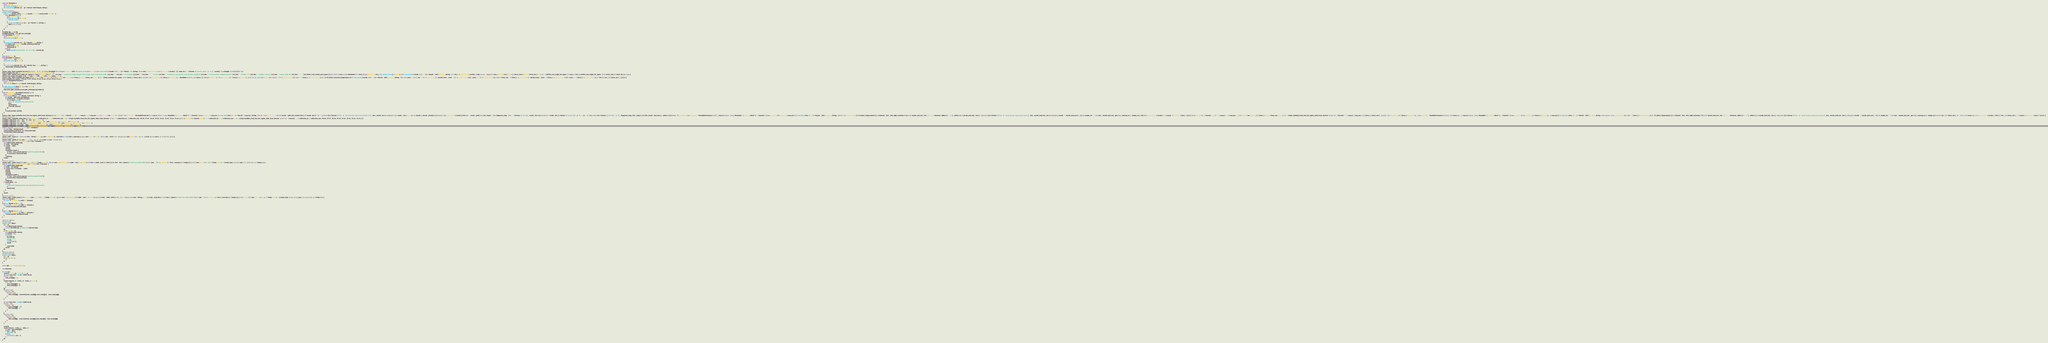Convert code to text. <code><loc_0><loc_0><loc_500><loc_500><_Rust_>pub trait Readable {
    type Output;
    fn words_count() -> usize;
    fn read_words(words: &[&str]) -> Result<Self::Output, String>;
}
#[macro_export]
macro_rules! readable {
    ( $ t : ty , $ words_count : expr , |$ words : ident | $ read_words : expr ) => {
        impl Readable for $t {
            type Output = $t;
            fn words_count() -> usize {
                $words_count
            }
            fn read_words($words: &[&str]) -> Result<$t, String> {
                Ok($read_words)
            }
        }
    };
}
readable!((), 1, |_ss| ());
readable!(String, 1, |ss| ss[0].to_string());
impl Readable for char {
    type Output = char;
    fn words_count() -> usize {
        1
    }
    fn read_words(words: &[&str]) -> Result<char, String> {
        let chars: Vec<char> = words[0].chars().collect();
        if chars.len() == 1 {
            Ok(chars[0])
        } else {
            Err(format!("cannot parse `{}` as a char", words[0]))
        }
    }
}
pub struct Chars();
impl Readable for Chars {
    type Output = Vec<char>;
    fn words_count() -> usize {
        1
    }
    fn read_words(words: &[&str]) -> Result<Vec<char>, String> {
        Ok(words[0].chars().collect())
    }
}
macro_rules ! impl_readable_for_ints { ( $ ( $ t : ty ) * ) => { $ ( impl Readable for $ t { type Output = Self ; fn words_count ( ) -> usize { 1 } fn read_words ( words : & [ & str ] ) -> Result <$ t , String > { use std :: str :: FromStr ; <$ t >:: from_str ( words [ 0 ] ) . map_err ( | _ | { format ! ( "cannot parse `{}` as {}" , words [ 0 ] , stringify ! ( $ t ) ) } ) } } ) * } ; }
impl_readable_for_ints ! ( i8 u8 i16 u16 i32 u32 i64 u64 isize usize f32 f64 ) ;
macro_rules ! define_one_origin_int_types { ( $ new_t : ident $ int_t : ty ) => { # [ doc = " Converts 1-origin integer into 0-origin when read from stdin." ] # [ doc = "" ] # [ doc = " # Example" ] # [ doc = "" ] # [ doc = " ```no_run" ] # [ doc = " # #[macro_use] extern crate atcoder_snippets;" ] # [ doc = " # use atcoder_snippets::read::*;" ] # [ doc = " // Stdin: \"1\"" ] # [ doc = " read!(a = usize_);" ] # [ doc = " assert_eq!(a, 0);" ] # [ doc = " ```" ] # [ allow ( non_camel_case_types ) ] pub struct $ new_t ; impl Readable for $ new_t { type Output = $ int_t ; fn words_count ( ) -> usize { 1 } fn read_words ( words : & [ & str ] ) -> Result < Self :: Output , String > { <$ int_t >:: read_words ( words ) . map ( | n | n - 1 ) } } } ; ( $ new_t : ident $ int_t : ty ; $ ( $ inner_new_t : ident $ inner_int_t : ty ) ;* ) => { define_one_origin_int_types ! ( $ new_t $ int_t ) ; define_one_origin_int_types ! ( $ ( $ inner_new_t $ inner_int_t ) ;* ) ; } ; }
define_one_origin_int_types ! ( u8_ u8 ; u16_ u16 ; u32_ u32 ; u64_ u64 ; usize_ usize ) ;
macro_rules ! impl_readable_for_tuples { ( $ t : ident $ var : ident ) => ( ) ; ( $ t : ident $ var : ident ; $ ( $ inner_t : ident $ inner_var : ident ) ;* ) => { impl_readable_for_tuples ! ( $ ( $ inner_t $ inner_var ) ;* ) ; impl <$ t : Readable , $ ( $ inner_t : Readable ) ,*> Readable for ( $ t , $ ( $ inner_t ) ,* ) { type Output = ( <$ t >:: Output , $ ( <$ inner_t >:: Output ) ,* ) ; fn words_count ( ) -> usize { let mut n = <$ t >:: words_count ( ) ; $ ( n += <$ inner_t >:: words_count ( ) ; ) * n } # [ allow ( unused_assignments ) ] fn read_words ( words : & [ & str ] ) -> Result < Self :: Output , String > { let mut start = 0 ; let $ var = <$ t >:: read_words ( & words [ start .. start +<$ t >:: words_count ( ) ] ) ?; start += <$ t >:: words_count ( ) ; $ ( let $ inner_var = <$ inner_t >:: read_words ( & words [ start .. start +<$ inner_t >:: words_count ( ) ] ) ?; start += <$ inner_t >:: words_count ( ) ; ) * Ok ( ( $ var , $ ( $ inner_var ) ,* ) ) } } } ; }
impl_readable_for_tuples ! ( T8 x8 ; T7 x7 ; T6 x6 ; T5 x5 ; T4 x4 ; T3 x3 ; T2 x2 ; T1 x1 ) ;
pub trait ReadableFromLine {
    type Output;
    fn read_line(line: &str) -> Result<Self::Output, String>;
}
fn split_into_words(line: &str) -> Vec<&str> {
    #[allow(deprecated)]
    line.trim_right_matches('\n').split_whitespace().collect()
}
impl<T: Readable> ReadableFromLine for T {
    type Output = T::Output;
    fn read_line(line: &str) -> Result<T::Output, String> {
        let words = split_into_words(line);
        if words.len() != T::words_count() {
            return Err(format!(
                "line `{}` has {} words, expected {}",
                line,
                words.len(),
                T::words_count()
            ));
        }
        T::read_words(&words)
    }
}
macro_rules ! impl_readable_from_line_for_tuples_with_from_iterator { ( $ u : ident : $ ( + $ bound : path ) * => $ seq_in : ty , $ seq_out : ty ; $ t : ident $ var : ident ) => { impl <$ u : Readable > ReadableFromLine for $ seq_in where <$ u as Readable >:: Output : Sized $ ( + $ bound ) * { type Output = $ seq_out ; fn read_line ( line : & str ) -> Result <$ seq_out , String > { let n = $ u :: words_count ( ) ; let words = split_into_words ( line ) ; if words . len ( ) % n != 0 { return Err ( format ! ( "line `{}` has {} words, expected multiple of {}" , line , words . len ( ) , n ) ) ; } let mut result = Vec :: new ( ) ; for chunk in words . chunks ( n ) { match $ u :: read_words ( chunk ) { Ok ( v ) => result . push ( v ) , Err ( msg ) => { let flagment_msg = if n == 1 { format ! ( "word {}" , result . len ( ) ) } else { let l = result . len ( ) ; format ! ( "words {}-{}" , n * l + 1 , ( n + 1 ) * l ) } ; return Err ( format ! ( "{} of line `{}`: {}" , flagment_msg , line , msg ) ) ; } } } Ok ( result . into_iter ( ) . collect ( ) ) } } impl < T : Readable , $ u : Readable > ReadableFromLine for ( T , $ seq_in ) where <$ u as Readable >:: Output : Sized $ ( + $ bound ) * { type Output = ( T :: Output , $ seq_out ) ; fn read_line ( line : & str ) -> Result < Self :: Output , String > { let n = T :: words_count ( ) ; # [ allow ( deprecated ) ] let trimmed = line . trim_right_matches ( '\n' ) ; let words_and_rest : Vec <& str > = trimmed . splitn ( n + 1 , ' ' ) . collect ( ) ; if words_and_rest . len ( ) < n { return Err ( format ! ( "line `{}` has {} words, expected at least {}" , line , words_and_rest . len ( ) , n ) ) ; } let words = & words_and_rest [ .. n ] ; let empty_str = "" ; let rest = words_and_rest . get ( n ) . unwrap_or ( & empty_str ) ; Ok ( ( T :: read_words ( words ) ?, <$ seq_in >:: read_line ( rest ) ? ) ) } } } ; ( $ u : ident : $ ( + $ bound : path ) * => $ seq_in : ty , $ seq_out : ty ; $ t : ident $ var : ident , $ ( $ inner_t : ident $ inner_var : ident ) ,+ ) => { impl_readable_from_line_for_tuples_with_from_iterator ! ( $ u : $ ( + $ bound ) * => $ seq_in , $ seq_out ; $ ( $ inner_t $ inner_var ) ,+ ) ; impl <$ t : Readable , $ ( $ inner_t : Readable ) ,+ , $ u : Readable > ReadableFromLine for ( $ t , $ ( $ inner_t ) ,+ , $ seq_in ) where <$ u as Readable >:: Output : Sized $ ( + $ bound ) * { type Output = ( $ t :: Output , $ ( $ inner_t :: Output ) ,+ , $ seq_out ) ; fn read_line ( line : & str ) -> Result < Self :: Output , String > { let mut n = $ t :: words_count ( ) ; $ ( n += $ inner_t :: words_count ( ) ; ) + # [ allow ( deprecated ) ] let trimmed = line . trim_right_matches ( '\n' ) ; let words_and_rest : Vec <& str > = trimmed . splitn ( n + 1 , ' ' ) . collect ( ) ; if words_and_rest . len ( ) < n { return Err ( format ! ( "line `{}` has {} words, expected at least {}" , line , words_and_rest . len ( ) , n ) ) ; } let words = & words_and_rest [ .. n ] ; let empty_str = "" ; let rest = words_and_rest . get ( n ) . unwrap_or ( & empty_str ) ; let ( $ var , $ ( $ inner_var ) ,* ) = < ( $ t , $ ( $ inner_t ) ,+ ) >:: read_words ( words ) ?; Ok ( ( $ var , $ ( $ inner_var ) ,* , <$ seq_in >:: read_line ( rest ) ? ) ) } } } ; }
#[macro_export]
macro_rules ! readable_collection { ( $ u : ident => $ collection_in : ty , $ collection_out : ty ) => { impl_readable_from_line_for_tuples_with_from_iterator ! ( $ u : => $ collection_in , $ collection_out ; T8 x8 , T7 x7 , T6 x6 , T5 x5 , T4 x4 , T3 x3 , T2 x2 , T1 x1 ) ; } ; ( $ u : ident : $ ( $ bound : path ) ,* => $ collection_in : ty , $ collection_out : ty ) => { impl_readable_from_line_for_tuples_with_from_iterator ! ( $ u : $ ( + $ bound ) * => $ collection_in , $ collection_out ; T8 x8 , T7 x7 , T6 x6 , T5 x5 , T4 x4 , T3 x3 , T2 x2 , T1 x1 ) ; } }
readable_collection ! ( U => Vec < U >, Vec < U :: Output > ) ;
readable_collection ! ( U => std :: collections :: VecDeque < U >, std :: collections :: VecDeque < U :: Output > ) ;
readable_collection ! ( U : Eq , std :: hash :: Hash => std :: collections :: HashSet < U >, std :: collections :: HashSet < U :: Output > ) ;
readable_collection ! ( U : Ord => std :: collections :: BTreeSet < U >, std :: collections :: BTreeSet < U :: Output > ) ;
readable_collection ! ( U : Ord => std :: collections :: BinaryHeap < U >, std :: collections :: BinaryHeap < U :: Output > ) ;
pub fn read<T: ReadableFromLine>() -> T::Output {
    let mut line = String::new();
    std::io::stdin().read_line(&mut line).unwrap();
    T::read_line(&line).unwrap()
}
#[macro_export]
macro_rules ! read { ( ) => { let mut line = String :: new ( ) ; std :: io :: stdin ( ) . read_line ( & mut line ) . unwrap ( ) ; } ; ( $ pat : pat = $ t : ty ) => { let $ pat = read ::<$ t > ( ) ; } ; ( $ ( $ pat : pat = $ t : ty ) ,+ ) => { read ! ( ( $ ( $ pat ) ,* ) = ( $ ( $ t ) ,* ) ) ; } ; }
#[macro_export]
macro_rules ! readls { ( $ ( $ pat : pat = $ t : ty ) ,+ ) => { $ ( read ! ( $ pat = $ t ) ; ) * } ; }
pub fn readx<T: ReadableFromLine>() -> Vec<T::Output> {
    use std::io::{self, BufRead};
    let stdin = io::stdin();
    let result = stdin
        .lock()
        .lines()
        .map(|line_result| {
            let line = line_result.expect("read from stdin failed");
            T::read_line(&line).unwrap()
        })
        .collect();
    result
}
#[macro_export]
macro_rules ! readx_loop { ( |$ pat : pat = $ t : ty | $ body : expr ) => { { use std :: io :: BufRead ; let stdin = std :: io :: stdin ( ) ; for line in stdin . lock ( ) . lines ( ) { let line = line . expect ( "read from stdin failed" ) ; let $ pat = <$ t >:: read_line ( & line ) . unwrap ( ) ; $ body } } } ; ( |$ ( $ pat : pat = $ t : ty ) ,*| $ body : expr ) => { readx_loop ! ( | ( $ ( $ pat ) ,* ) = ( $ ( $ t ) ,* ) | $ body ) ; } ; }
pub fn readn<T: ReadableFromLine>(n: usize) -> Vec<T::Output> {
    use std::io::{self, BufRead};
    let stdin = io::stdin();
    let result: Vec<T::Output> = stdin
        .lock()
        .lines()
        .take(n)
        .map(|line_result| {
            let line = line_result.expect("read from stdin failed");
            T::read_line(&line).unwrap()
        })
        .collect();
    if result.len() < n {
        panic!(
            "expected reading {} lines, but only {} lines are read",
            n,
            result.len()
        );
    }
    result
}
#[macro_export]
macro_rules ! readn_loop { ( $ n : expr , |$ pat : pat = $ t : ty | $ body : expr ) => { { use std :: io :: BufRead ; let stdin = std :: io :: stdin ( ) ; let mut lock = stdin . lock ( ) ; for _ in 0 ..$ n { let mut line = String :: new ( ) ; lock . read_line ( & mut line ) . expect ( "read from stdin failed" ) ; let $ pat = <$ t >:: read_line ( & line ) . unwrap ( ) ; $ body } } } ; ( $ n : expr , |$ ( $ pat : pat = $ t : ty ) ,*| $ body : expr ) => { readn_loop ! ( $ n , | ( $ ( $ pat ) ,* ) = ( $ ( $ t ) ,* ) | $ body ) ; } ; }
pub trait Words {
    fn read<T: Readable>(&self) -> T::Output;
}
impl<'a> Words for [&'a str] {
    fn read<T: Readable>(&self) -> T::Output {
        T::read_words(self).unwrap()
    }
}
impl<'a> Words for &'a str {
    fn read<T: Readable>(&self) -> T::Output {
        T::read_words(&[self]).unwrap()
    }
}

#[macro_export]
#[cfg(local)]
macro_rules! dbg {
    ( ) => {{
        use std::io::{self, Write};
        writeln!(io::stderr(), "{}: dbg", line!()).unwrap();
    }};
    ( $ e : expr ) => {{
        use std::io::{self, Write};
        let result = $e;
        writeln!(
            io::stderr(),
            "{}: {} = {:?}",
            line!(),
            stringify!($e),
            result
        )
            .unwrap();
        result
    }};
}
#[macro_export]
#[cfg(not(local))]
macro_rules! dbg {
    ( ) => {};
    ( $ e : expr ) => {
        $e
    };
}

const INF: u64 = 1_000_000_001;

use std::cmp;

fn main() {
    read!(n = usize, m = usize, l = u64);
    let mut cost_mat = vec![vec![INF; n]; n];
    for i in 0..n {
        cost_mat[i][i] = 0;
    }
    readn_loop!(m, |a = usize_, b = usize_, c = u64| {
        if c <= l {
            cost_mat[a][b] = c;
            cost_mat[b][a] = c;
        }
    });
    for v in 0..n {
        for i in 0..n {
            for j in 0..n {
                cost_mat[i][j] = cmp::min(cost_mat[i][j], cost_mat[i][v] + cost_mat[v][j]);
            }
        }
    }

    let mut fuel_mat = vec![vec![INF; n]; n];
    for i in 0..n {
        for j in 0..n {
            if cost_mat[i][j] <= l {
                fuel_mat[i][j] = 1;
            }
        }
    }
    for v in 0..n {
        for i in 0..n {
            for j in 0..n {
                fuel_mat[i][j] = cmp::min(fuel_mat[i][j], fuel_mat[i][v] + fuel_mat[v][j]);
            }
        }
    }

    read!();
    readx_loop!(|s = usize_, t = usize_| {
        let ans = fuel_mat[s][t];
        if ans >= INF {
            println!("-1");
        } else {
            println!("{}", ans - 1);
        }
    });
}
</code> 